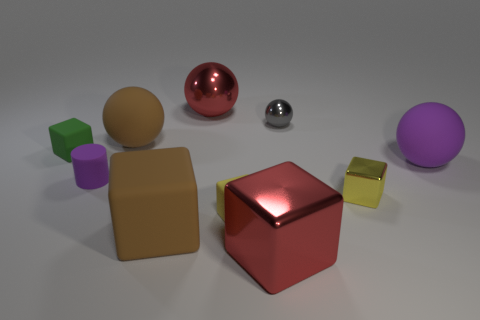Do the red cube and the gray shiny sphere have the same size?
Offer a terse response. No. There is a tiny thing that is both left of the yellow metal cube and in front of the purple cylinder; what is its color?
Your answer should be very brief. Yellow. What number of tiny gray things have the same material as the cylinder?
Keep it short and to the point. 0. What number of yellow cubes are there?
Provide a succinct answer. 2. There is a green matte cube; is it the same size as the red metallic object that is behind the small cylinder?
Offer a terse response. No. There is a object that is to the left of the purple matte object that is to the left of the large metallic sphere; what is it made of?
Your answer should be compact. Rubber. There is a purple object to the left of the metal block that is right of the big metal object on the right side of the small yellow rubber cube; what is its size?
Provide a short and direct response. Small. Do the gray object and the red shiny object that is behind the large brown matte block have the same shape?
Provide a short and direct response. Yes. What is the green object made of?
Your answer should be compact. Rubber. How many metallic objects are either small yellow cubes or big purple balls?
Your answer should be very brief. 1. 